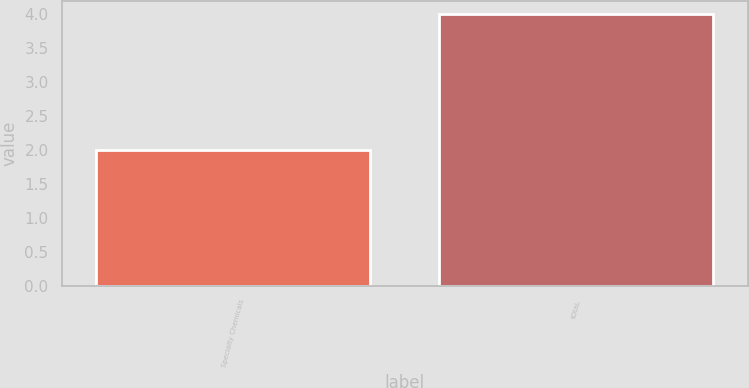Convert chart to OTSL. <chart><loc_0><loc_0><loc_500><loc_500><bar_chart><fcel>Specialty Chemicals<fcel>tOtaL<nl><fcel>2<fcel>4<nl></chart> 